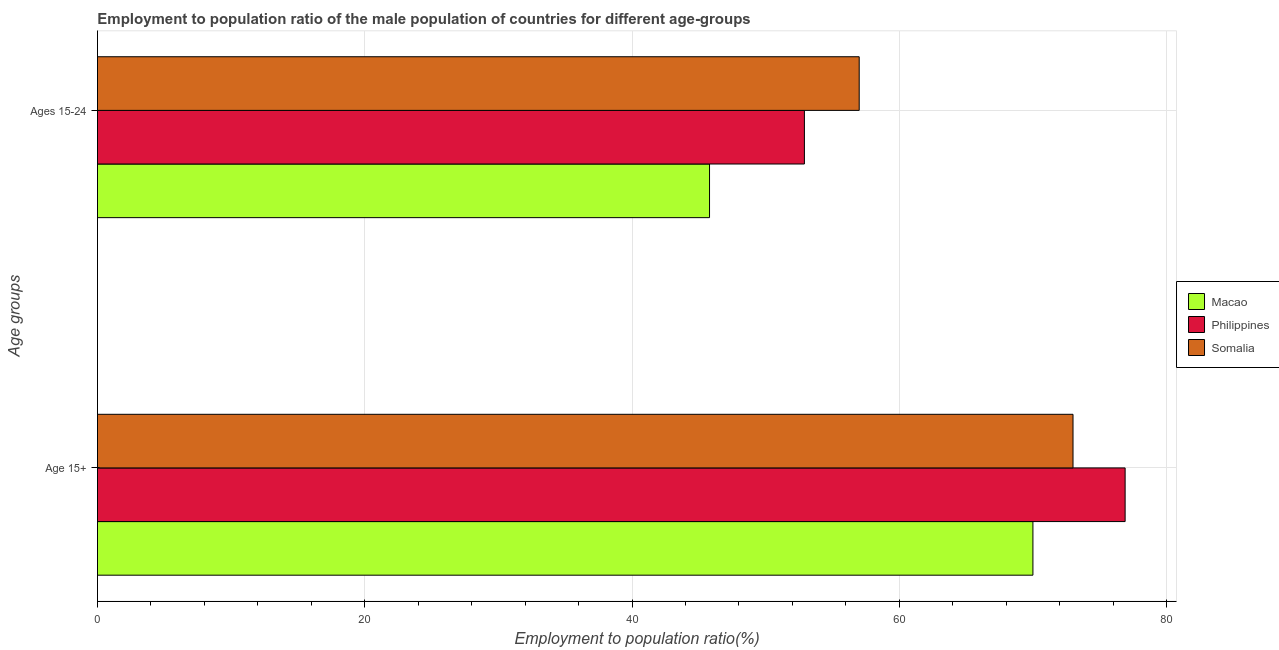Are the number of bars per tick equal to the number of legend labels?
Give a very brief answer. Yes. Are the number of bars on each tick of the Y-axis equal?
Provide a short and direct response. Yes. How many bars are there on the 2nd tick from the bottom?
Provide a succinct answer. 3. What is the label of the 2nd group of bars from the top?
Ensure brevity in your answer.  Age 15+. Across all countries, what is the maximum employment to population ratio(age 15+)?
Give a very brief answer. 76.9. In which country was the employment to population ratio(age 15-24) minimum?
Provide a short and direct response. Macao. What is the total employment to population ratio(age 15-24) in the graph?
Your answer should be compact. 155.7. What is the difference between the employment to population ratio(age 15-24) in Somalia and that in Macao?
Provide a succinct answer. 11.2. What is the difference between the employment to population ratio(age 15+) in Philippines and the employment to population ratio(age 15-24) in Somalia?
Give a very brief answer. 19.9. What is the average employment to population ratio(age 15-24) per country?
Ensure brevity in your answer.  51.9. What is the difference between the employment to population ratio(age 15+) and employment to population ratio(age 15-24) in Philippines?
Provide a short and direct response. 24. In how many countries, is the employment to population ratio(age 15-24) greater than 36 %?
Provide a succinct answer. 3. What is the ratio of the employment to population ratio(age 15-24) in Macao to that in Philippines?
Your response must be concise. 0.87. Is the employment to population ratio(age 15-24) in Philippines less than that in Macao?
Your answer should be compact. No. What does the 2nd bar from the top in Age 15+ represents?
Provide a short and direct response. Philippines. What does the 3rd bar from the bottom in Ages 15-24 represents?
Your answer should be very brief. Somalia. How many bars are there?
Offer a terse response. 6. Are all the bars in the graph horizontal?
Provide a succinct answer. Yes. How many countries are there in the graph?
Your answer should be compact. 3. What is the difference between two consecutive major ticks on the X-axis?
Offer a terse response. 20. Are the values on the major ticks of X-axis written in scientific E-notation?
Keep it short and to the point. No. Does the graph contain grids?
Ensure brevity in your answer.  Yes. Where does the legend appear in the graph?
Keep it short and to the point. Center right. How many legend labels are there?
Make the answer very short. 3. How are the legend labels stacked?
Your answer should be compact. Vertical. What is the title of the graph?
Your answer should be compact. Employment to population ratio of the male population of countries for different age-groups. What is the label or title of the X-axis?
Your answer should be compact. Employment to population ratio(%). What is the label or title of the Y-axis?
Keep it short and to the point. Age groups. What is the Employment to population ratio(%) in Philippines in Age 15+?
Your answer should be compact. 76.9. What is the Employment to population ratio(%) of Somalia in Age 15+?
Provide a short and direct response. 73. What is the Employment to population ratio(%) in Macao in Ages 15-24?
Your response must be concise. 45.8. What is the Employment to population ratio(%) of Philippines in Ages 15-24?
Your response must be concise. 52.9. Across all Age groups, what is the maximum Employment to population ratio(%) in Philippines?
Your answer should be very brief. 76.9. Across all Age groups, what is the minimum Employment to population ratio(%) of Macao?
Provide a succinct answer. 45.8. Across all Age groups, what is the minimum Employment to population ratio(%) in Philippines?
Offer a terse response. 52.9. Across all Age groups, what is the minimum Employment to population ratio(%) of Somalia?
Provide a succinct answer. 57. What is the total Employment to population ratio(%) of Macao in the graph?
Provide a short and direct response. 115.8. What is the total Employment to population ratio(%) in Philippines in the graph?
Offer a very short reply. 129.8. What is the total Employment to population ratio(%) in Somalia in the graph?
Provide a succinct answer. 130. What is the difference between the Employment to population ratio(%) of Macao in Age 15+ and that in Ages 15-24?
Give a very brief answer. 24.2. What is the difference between the Employment to population ratio(%) in Somalia in Age 15+ and that in Ages 15-24?
Give a very brief answer. 16. What is the difference between the Employment to population ratio(%) of Macao in Age 15+ and the Employment to population ratio(%) of Philippines in Ages 15-24?
Your answer should be compact. 17.1. What is the average Employment to population ratio(%) of Macao per Age groups?
Your answer should be very brief. 57.9. What is the average Employment to population ratio(%) in Philippines per Age groups?
Make the answer very short. 64.9. What is the average Employment to population ratio(%) in Somalia per Age groups?
Your response must be concise. 65. What is the difference between the Employment to population ratio(%) of Macao and Employment to population ratio(%) of Philippines in Age 15+?
Your answer should be compact. -6.9. What is the difference between the Employment to population ratio(%) of Philippines and Employment to population ratio(%) of Somalia in Age 15+?
Give a very brief answer. 3.9. What is the difference between the Employment to population ratio(%) in Macao and Employment to population ratio(%) in Somalia in Ages 15-24?
Offer a terse response. -11.2. What is the ratio of the Employment to population ratio(%) of Macao in Age 15+ to that in Ages 15-24?
Your response must be concise. 1.53. What is the ratio of the Employment to population ratio(%) in Philippines in Age 15+ to that in Ages 15-24?
Your answer should be very brief. 1.45. What is the ratio of the Employment to population ratio(%) of Somalia in Age 15+ to that in Ages 15-24?
Keep it short and to the point. 1.28. What is the difference between the highest and the second highest Employment to population ratio(%) of Macao?
Your response must be concise. 24.2. What is the difference between the highest and the lowest Employment to population ratio(%) in Macao?
Your response must be concise. 24.2. What is the difference between the highest and the lowest Employment to population ratio(%) of Philippines?
Make the answer very short. 24. What is the difference between the highest and the lowest Employment to population ratio(%) of Somalia?
Keep it short and to the point. 16. 